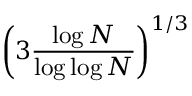<formula> <loc_0><loc_0><loc_500><loc_500>\left ( 3 { \frac { \log N } { \log \log N } } \right ) ^ { 1 / 3 }</formula> 